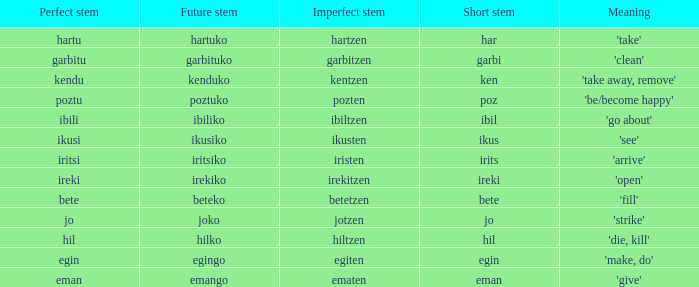Parse the table in full. {'header': ['Perfect stem', 'Future stem', 'Imperfect stem', 'Short stem', 'Meaning'], 'rows': [['hartu', 'hartuko', 'hartzen', 'har', "'take'"], ['garbitu', 'garbituko', 'garbitzen', 'garbi', "'clean'"], ['kendu', 'kenduko', 'kentzen', 'ken', "'take away, remove'"], ['poztu', 'poztuko', 'pozten', 'poz', "'be/become happy'"], ['ibili', 'ibiliko', 'ibiltzen', 'ibil', "'go about'"], ['ikusi', 'ikusiko', 'ikusten', 'ikus', "'see'"], ['iritsi', 'iritsiko', 'iristen', 'irits', "'arrive'"], ['ireki', 'irekiko', 'irekitzen', 'ireki', "'open'"], ['bete', 'beteko', 'betetzen', 'bete', "'fill'"], ['jo', 'joko', 'jotzen', 'jo', "'strike'"], ['hil', 'hilko', 'hiltzen', 'hil', "'die, kill'"], ['egin', 'egingo', 'egiten', 'egin', "'make, do'"], ['eman', 'emango', 'ematen', 'eman', "'give'"]]} What is the figure for future stem for poztu? 1.0. 